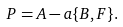Convert formula to latex. <formula><loc_0><loc_0><loc_500><loc_500>P = A - a \{ B , F \} .</formula> 